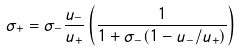<formula> <loc_0><loc_0><loc_500><loc_500>\sigma _ { + } = \sigma _ { - } \frac { u _ { - } } { u _ { + } } \left ( \frac { 1 } { 1 + \sigma _ { - } ( 1 - u _ { - } / u _ { + } ) } \right )</formula> 